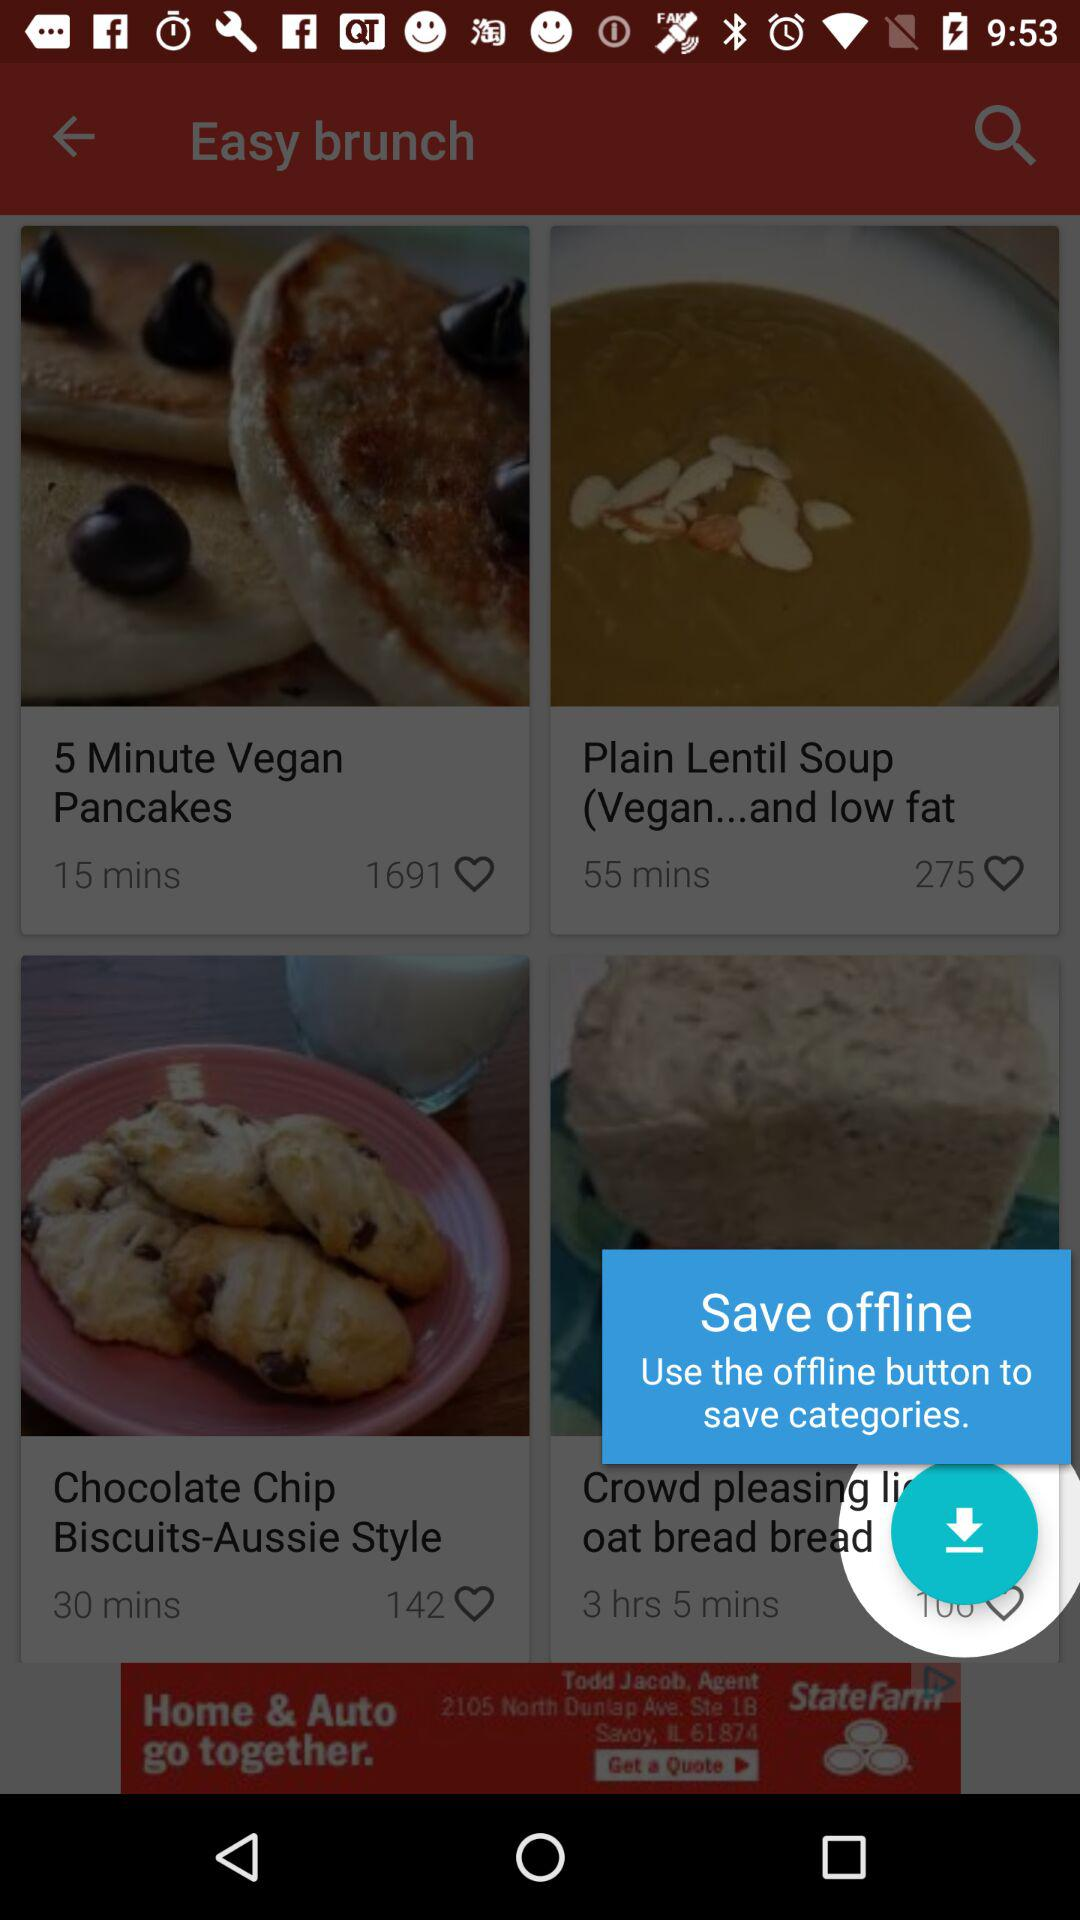What are the easy brunches? The easy brunches are "5 Minute Vegan Pancakes", "Plain Lentil Soup (Vegan...and low fat" and "Chocolate Chip Biscuits-Aussie Style". 